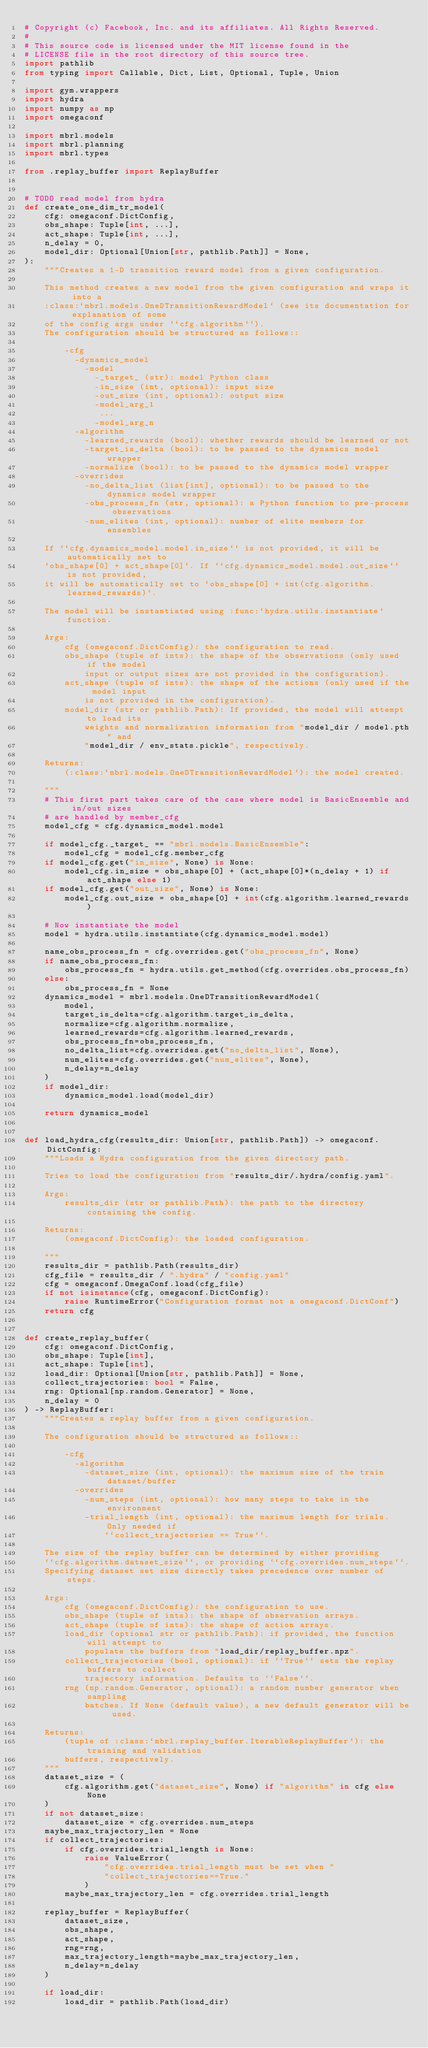Convert code to text. <code><loc_0><loc_0><loc_500><loc_500><_Python_># Copyright (c) Facebook, Inc. and its affiliates. All Rights Reserved.
#
# This source code is licensed under the MIT license found in the
# LICENSE file in the root directory of this source tree.
import pathlib
from typing import Callable, Dict, List, Optional, Tuple, Union

import gym.wrappers
import hydra
import numpy as np
import omegaconf

import mbrl.models
import mbrl.planning
import mbrl.types

from .replay_buffer import ReplayBuffer


# TODO read model from hydra
def create_one_dim_tr_model(
    cfg: omegaconf.DictConfig,
    obs_shape: Tuple[int, ...],
    act_shape: Tuple[int, ...],
    n_delay = 0,
    model_dir: Optional[Union[str, pathlib.Path]] = None,
):
    """Creates a 1-D transition reward model from a given configuration.

    This method creates a new model from the given configuration and wraps it into a
    :class:`mbrl.models.OneDTransitionRewardModel` (see its documentation for explanation of some
    of the config args under ``cfg.algorithm``).
    The configuration should be structured as follows::

        -cfg
          -dynamics_model
            -model
              -_target_ (str): model Python class
              -in_size (int, optional): input size
              -out_size (int, optional): output size
              -model_arg_1
               ...
              -model_arg_n
          -algorithm
            -learned_rewards (bool): whether rewards should be learned or not
            -target_is_delta (bool): to be passed to the dynamics model wrapper
            -normalize (bool): to be passed to the dynamics model wrapper
          -overrides
            -no_delta_list (list[int], optional): to be passed to the dynamics model wrapper
            -obs_process_fn (str, optional): a Python function to pre-process observations
            -num_elites (int, optional): number of elite members for ensembles

    If ``cfg.dynamics_model.model.in_size`` is not provided, it will be automatically set to
    `obs_shape[0] + act_shape[0]`. If ``cfg.dynamics_model.model.out_size`` is not provided,
    it will be automatically set to `obs_shape[0] + int(cfg.algorithm.learned_rewards)`.

    The model will be instantiated using :func:`hydra.utils.instantiate` function.

    Args:
        cfg (omegaconf.DictConfig): the configuration to read.
        obs_shape (tuple of ints): the shape of the observations (only used if the model
            input or output sizes are not provided in the configuration).
        act_shape (tuple of ints): the shape of the actions (only used if the model input
            is not provided in the configuration).
        model_dir (str or pathlib.Path): If provided, the model will attempt to load its
            weights and normalization information from "model_dir / model.pth" and
            "model_dir / env_stats.pickle", respectively.

    Returns:
        (:class:`mbrl.models.OneDTransitionRewardModel`): the model created.

    """
    # This first part takes care of the case where model is BasicEnsemble and in/out sizes
    # are handled by member_cfg
    model_cfg = cfg.dynamics_model.model

    if model_cfg._target_ == "mbrl.models.BasicEnsemble":
        model_cfg = model_cfg.member_cfg
    if model_cfg.get("in_size", None) is None:
        model_cfg.in_size = obs_shape[0] + (act_shape[0]*(n_delay + 1) if act_shape else 1)
    if model_cfg.get("out_size", None) is None:
        model_cfg.out_size = obs_shape[0] + int(cfg.algorithm.learned_rewards)

    # Now instantiate the model
    model = hydra.utils.instantiate(cfg.dynamics_model.model)

    name_obs_process_fn = cfg.overrides.get("obs_process_fn", None)
    if name_obs_process_fn:
        obs_process_fn = hydra.utils.get_method(cfg.overrides.obs_process_fn)
    else:
        obs_process_fn = None
    dynamics_model = mbrl.models.OneDTransitionRewardModel(
        model,
        target_is_delta=cfg.algorithm.target_is_delta,
        normalize=cfg.algorithm.normalize,
        learned_rewards=cfg.algorithm.learned_rewards,
        obs_process_fn=obs_process_fn,
        no_delta_list=cfg.overrides.get("no_delta_list", None),
        num_elites=cfg.overrides.get("num_elites", None),
        n_delay=n_delay
    )
    if model_dir:
        dynamics_model.load(model_dir)

    return dynamics_model


def load_hydra_cfg(results_dir: Union[str, pathlib.Path]) -> omegaconf.DictConfig:
    """Loads a Hydra configuration from the given directory path.

    Tries to load the configuration from "results_dir/.hydra/config.yaml".

    Args:
        results_dir (str or pathlib.Path): the path to the directory containing the config.

    Returns:
        (omegaconf.DictConfig): the loaded configuration.

    """
    results_dir = pathlib.Path(results_dir)
    cfg_file = results_dir / ".hydra" / "config.yaml"
    cfg = omegaconf.OmegaConf.load(cfg_file)
    if not isinstance(cfg, omegaconf.DictConfig):
        raise RuntimeError("Configuration format not a omegaconf.DictConf")
    return cfg


def create_replay_buffer(
    cfg: omegaconf.DictConfig,
    obs_shape: Tuple[int],
    act_shape: Tuple[int],
    load_dir: Optional[Union[str, pathlib.Path]] = None,
    collect_trajectories: bool = False,
    rng: Optional[np.random.Generator] = None,
    n_delay = 0
) -> ReplayBuffer:
    """Creates a replay buffer from a given configuration.

    The configuration should be structured as follows::

        -cfg
          -algorithm
            -dataset_size (int, optional): the maximum size of the train dataset/buffer
          -overrides
            -num_steps (int, optional): how many steps to take in the environment
            -trial_length (int, optional): the maximum length for trials. Only needed if
                ``collect_trajectories == True``.

    The size of the replay buffer can be determined by either providing
    ``cfg.algorithm.dataset_size``, or providing ``cfg.overrides.num_steps``.
    Specifying dataset set size directly takes precedence over number of steps.

    Args:
        cfg (omegaconf.DictConfig): the configuration to use.
        obs_shape (tuple of ints): the shape of observation arrays.
        act_shape (tuple of ints): the shape of action arrays.
        load_dir (optional str or pathlib.Path): if provided, the function will attempt to
            populate the buffers from "load_dir/replay_buffer.npz".
        collect_trajectories (bool, optional): if ``True`` sets the replay buffers to collect
            trajectory information. Defaults to ``False``.
        rng (np.random.Generator, optional): a random number generator when sampling
            batches. If None (default value), a new default generator will be used.

    Returns:
        (tuple of :class:`mbrl.replay_buffer.IterableReplayBuffer`): the training and validation
        buffers, respectively.
    """
    dataset_size = (
        cfg.algorithm.get("dataset_size", None) if "algorithm" in cfg else None
    )
    if not dataset_size:
        dataset_size = cfg.overrides.num_steps
    maybe_max_trajectory_len = None
    if collect_trajectories:
        if cfg.overrides.trial_length is None:
            raise ValueError(
                "cfg.overrides.trial_length must be set when "
                "collect_trajectories==True."
            )
        maybe_max_trajectory_len = cfg.overrides.trial_length

    replay_buffer = ReplayBuffer(
        dataset_size,
        obs_shape,
        act_shape,
        rng=rng,
        max_trajectory_length=maybe_max_trajectory_len,
        n_delay=n_delay
    )

    if load_dir:
        load_dir = pathlib.Path(load_dir)</code> 